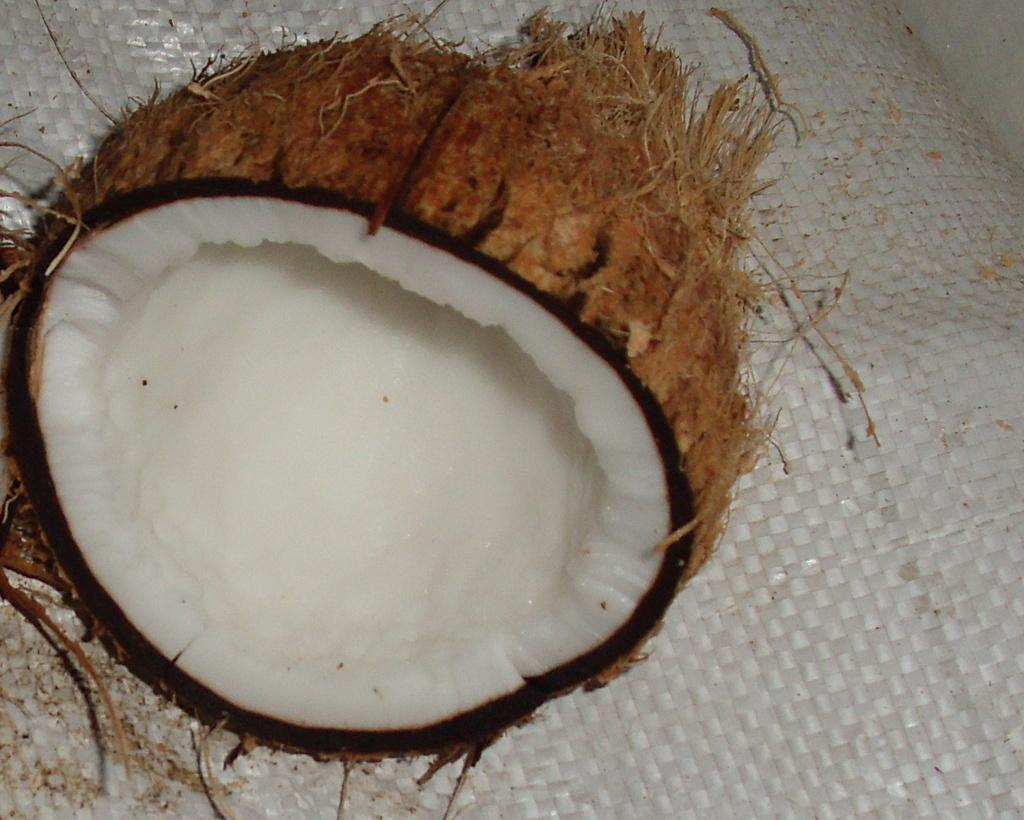What is the main subject in the center of the image? There is a coconut in the center of the image. What can be seen at the bottom of the image? There is a cover at the bottom of the image. What type of grass is growing around the coconut in the image? There is no grass visible in the image; it only features a coconut and a cover. What type of wine is being served in the image? There is no wine present in the image; it only features a coconut and a cover. 